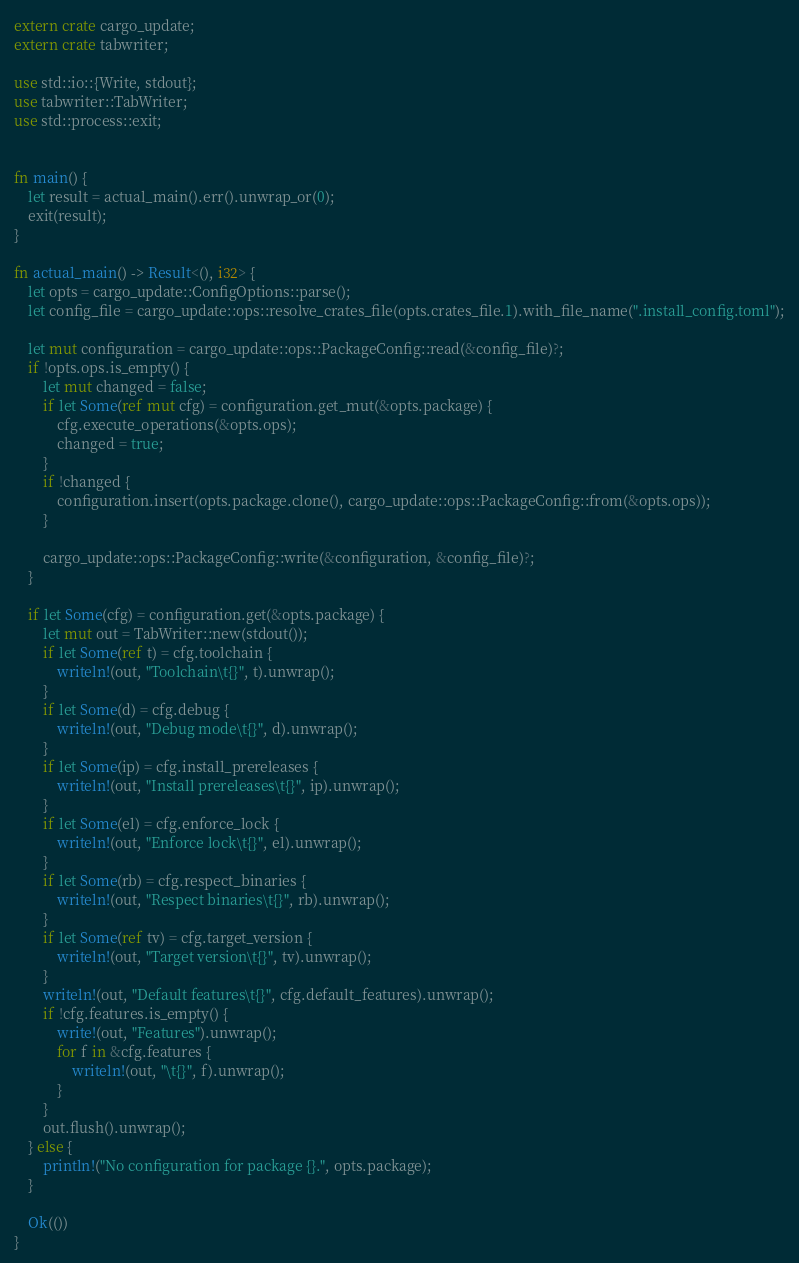Convert code to text. <code><loc_0><loc_0><loc_500><loc_500><_Rust_>extern crate cargo_update;
extern crate tabwriter;

use std::io::{Write, stdout};
use tabwriter::TabWriter;
use std::process::exit;


fn main() {
    let result = actual_main().err().unwrap_or(0);
    exit(result);
}

fn actual_main() -> Result<(), i32> {
    let opts = cargo_update::ConfigOptions::parse();
    let config_file = cargo_update::ops::resolve_crates_file(opts.crates_file.1).with_file_name(".install_config.toml");

    let mut configuration = cargo_update::ops::PackageConfig::read(&config_file)?;
    if !opts.ops.is_empty() {
        let mut changed = false;
        if let Some(ref mut cfg) = configuration.get_mut(&opts.package) {
            cfg.execute_operations(&opts.ops);
            changed = true;
        }
        if !changed {
            configuration.insert(opts.package.clone(), cargo_update::ops::PackageConfig::from(&opts.ops));
        }

        cargo_update::ops::PackageConfig::write(&configuration, &config_file)?;
    }

    if let Some(cfg) = configuration.get(&opts.package) {
        let mut out = TabWriter::new(stdout());
        if let Some(ref t) = cfg.toolchain {
            writeln!(out, "Toolchain\t{}", t).unwrap();
        }
        if let Some(d) = cfg.debug {
            writeln!(out, "Debug mode\t{}", d).unwrap();
        }
        if let Some(ip) = cfg.install_prereleases {
            writeln!(out, "Install prereleases\t{}", ip).unwrap();
        }
        if let Some(el) = cfg.enforce_lock {
            writeln!(out, "Enforce lock\t{}", el).unwrap();
        }
        if let Some(rb) = cfg.respect_binaries {
            writeln!(out, "Respect binaries\t{}", rb).unwrap();
        }
        if let Some(ref tv) = cfg.target_version {
            writeln!(out, "Target version\t{}", tv).unwrap();
        }
        writeln!(out, "Default features\t{}", cfg.default_features).unwrap();
        if !cfg.features.is_empty() {
            write!(out, "Features").unwrap();
            for f in &cfg.features {
                writeln!(out, "\t{}", f).unwrap();
            }
        }
        out.flush().unwrap();
    } else {
        println!("No configuration for package {}.", opts.package);
    }

    Ok(())
}
</code> 